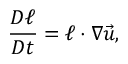Convert formula to latex. <formula><loc_0><loc_0><loc_500><loc_500>\frac { D \ell } { D t } = \ell \cdot \nabla \vec { u } ,</formula> 